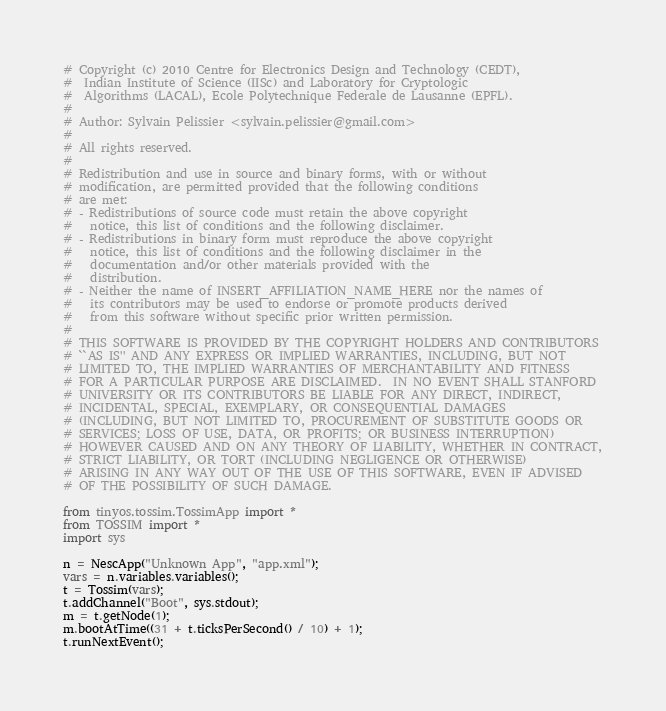<code> <loc_0><loc_0><loc_500><loc_500><_Python_># Copyright (c) 2010 Centre for Electronics Design and Technology (CEDT),
#  Indian Institute of Science (IISc) and Laboratory for Cryptologic 
#  Algorithms (LACAL), Ecole Polytechnique Federale de Lausanne (EPFL).
#
# Author: Sylvain Pelissier <sylvain.pelissier@gmail.com>
#
# All rights reserved.
#
# Redistribution and use in source and binary forms, with or without
# modification, are permitted provided that the following conditions
# are met:
# - Redistributions of source code must retain the above copyright
#   notice, this list of conditions and the following disclaimer.
# - Redistributions in binary form must reproduce the above copyright
#   notice, this list of conditions and the following disclaimer in the
#   documentation and/or other materials provided with the
#   distribution.
# - Neither the name of INSERT_AFFILIATION_NAME_HERE nor the names of
#   its contributors may be used to endorse or promote products derived
#   from this software without specific prior written permission.
#
# THIS SOFTWARE IS PROVIDED BY THE COPYRIGHT HOLDERS AND CONTRIBUTORS
# ``AS IS'' AND ANY EXPRESS OR IMPLIED WARRANTIES, INCLUDING, BUT NOT
# LIMITED TO, THE IMPLIED WARRANTIES OF MERCHANTABILITY AND FITNESS
# FOR A PARTICULAR PURPOSE ARE DISCLAIMED.  IN NO EVENT SHALL STANFORD
# UNIVERSITY OR ITS CONTRIBUTORS BE LIABLE FOR ANY DIRECT, INDIRECT,
# INCIDENTAL, SPECIAL, EXEMPLARY, OR CONSEQUENTIAL DAMAGES
# (INCLUDING, BUT NOT LIMITED TO, PROCUREMENT OF SUBSTITUTE GOODS OR
# SERVICES; LOSS OF USE, DATA, OR PROFITS; OR BUSINESS INTERRUPTION)
# HOWEVER CAUSED AND ON ANY THEORY OF LIABILITY, WHETHER IN CONTRACT,
# STRICT LIABILITY, OR TORT (INCLUDING NEGLIGENCE OR OTHERWISE)
# ARISING IN ANY WAY OUT OF THE USE OF THIS SOFTWARE, EVEN IF ADVISED
# OF THE POSSIBILITY OF SUCH DAMAGE.

from tinyos.tossim.TossimApp import *
from TOSSIM import *
import sys

n = NescApp("Unknown App", "app.xml");
vars = n.variables.variables();
t = Tossim(vars);
t.addChannel("Boot", sys.stdout);
m = t.getNode(1);
m.bootAtTime((31 + t.ticksPerSecond() / 10) + 1);
t.runNextEvent();
</code> 